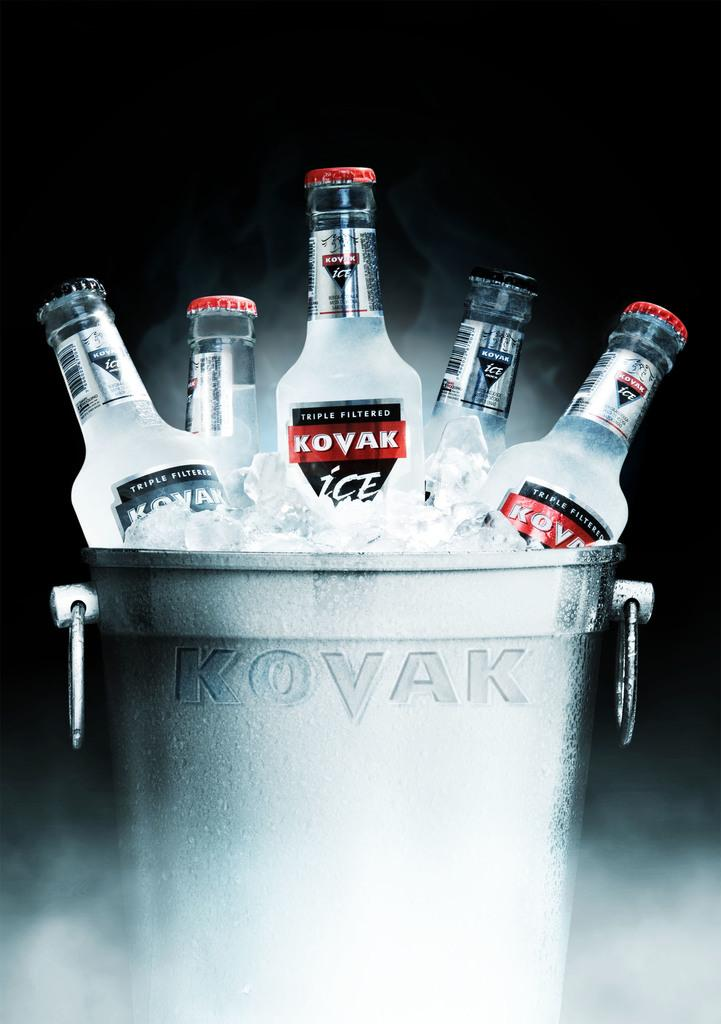<image>
Relay a brief, clear account of the picture shown. Several bottles of Kovak Ice sit in an ice bucket with Kovak written on its side. 